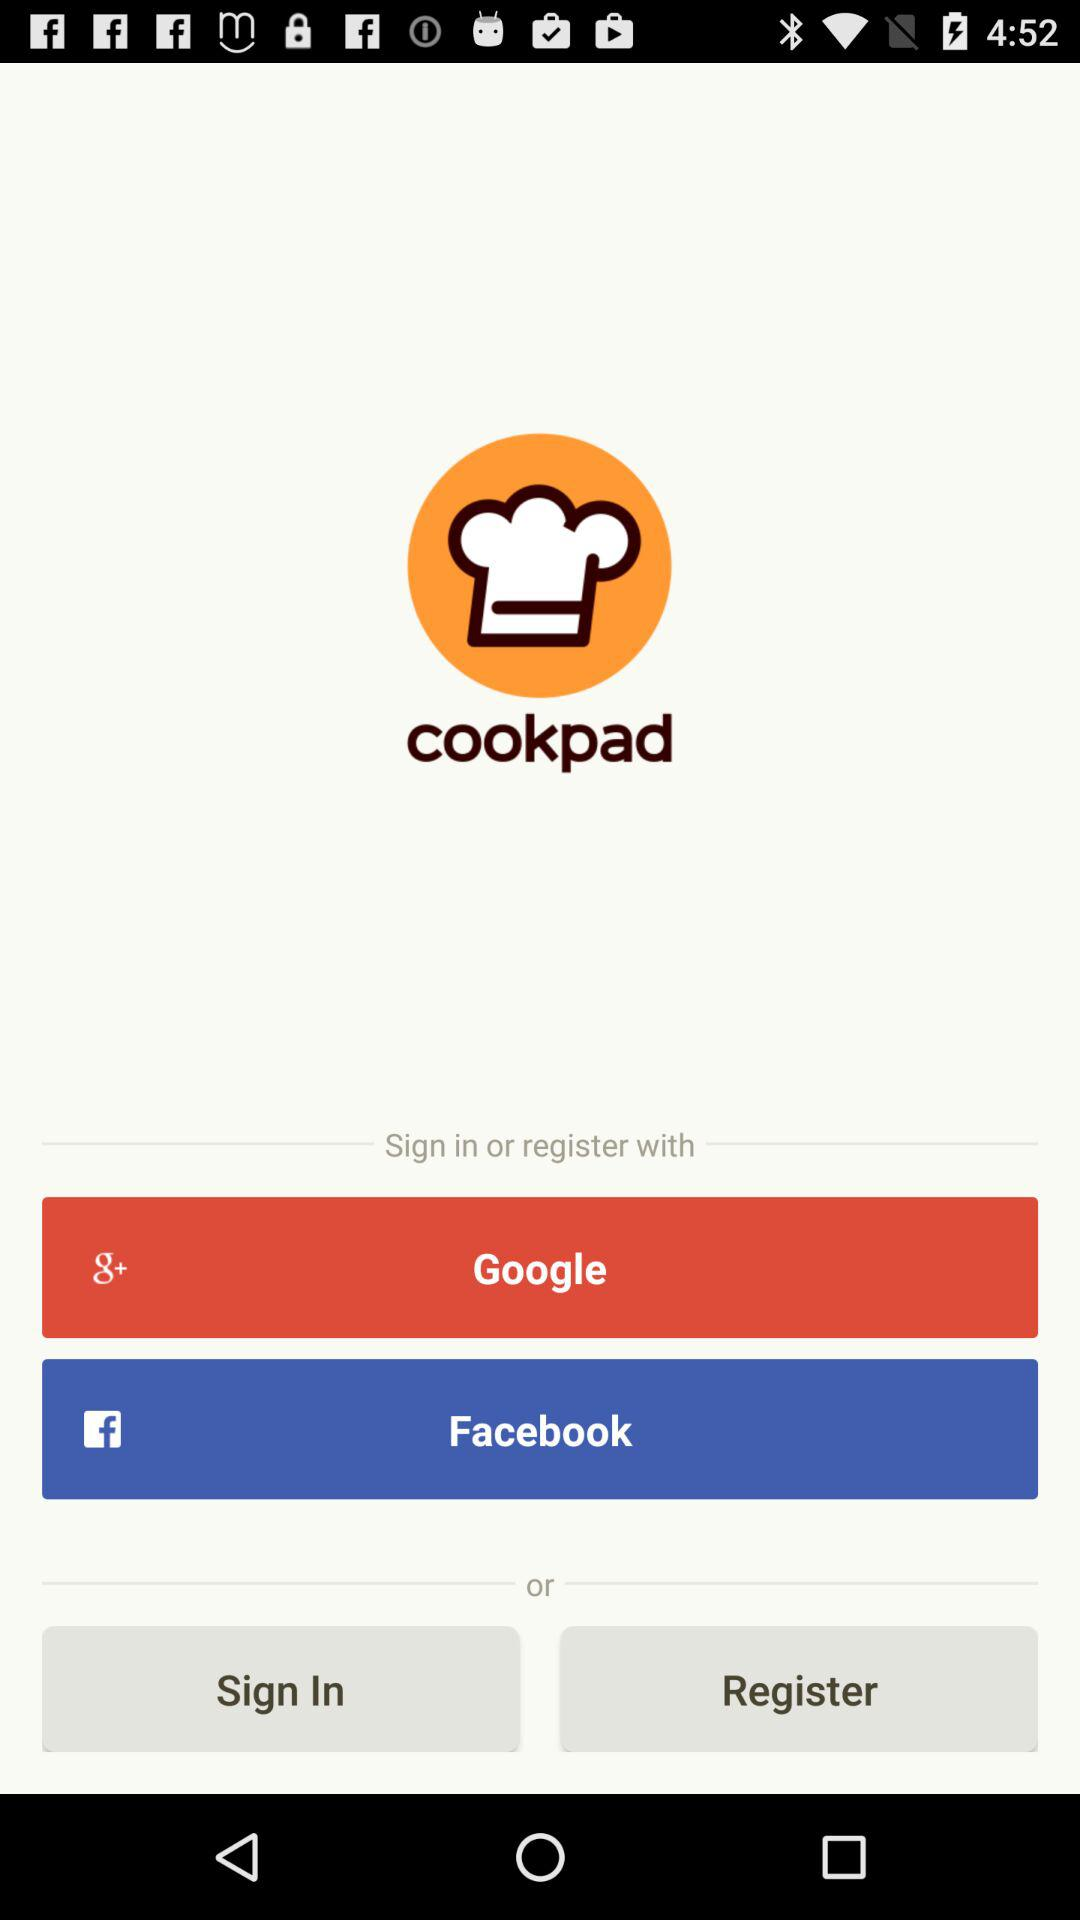What are the sign in options? The sign in options are "Google" and "Facebook". 